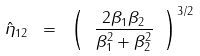Convert formula to latex. <formula><loc_0><loc_0><loc_500><loc_500>\hat { \eta } _ { 1 2 } \ = \ \left ( \ \frac { 2 { \beta } _ { 1 } { \beta } _ { 2 } } { { \beta } _ { 1 } ^ { 2 } + { \beta } _ { 2 } ^ { 2 } } \ \right ) ^ { 3 / 2 }</formula> 